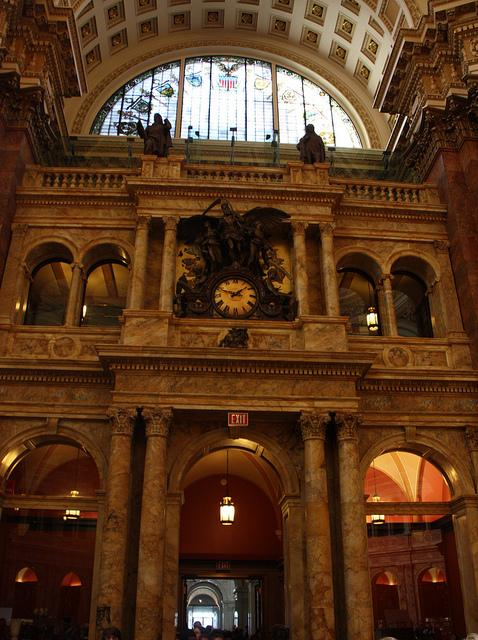What ensigns are shown at the top most part of this building? american 